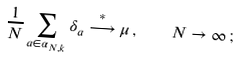Convert formula to latex. <formula><loc_0><loc_0><loc_500><loc_500>\frac { 1 } { N } \sum _ { a \in \alpha _ { N , k } } \delta _ { a } \stackrel { * } { \longrightarrow } \mu \, , \quad N \rightarrow \infty \, ;</formula> 